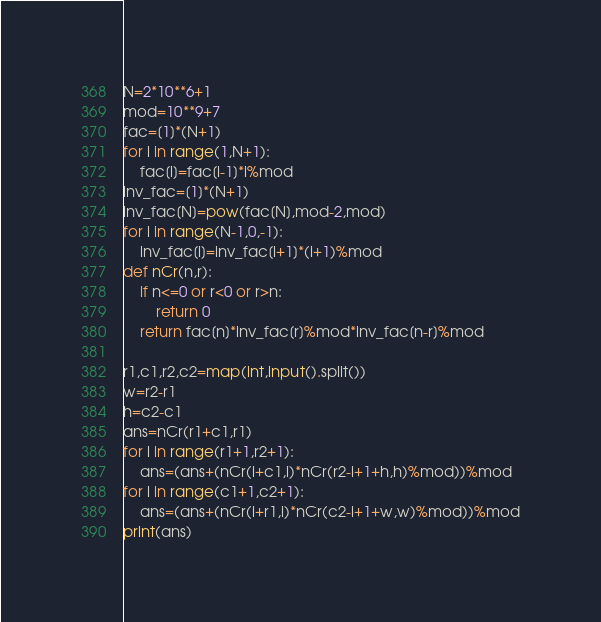Convert code to text. <code><loc_0><loc_0><loc_500><loc_500><_Python_>N=2*10**6+1
mod=10**9+7
fac=[1]*(N+1)
for i in range(1,N+1):
    fac[i]=fac[i-1]*i%mod
inv_fac=[1]*(N+1)
inv_fac[N]=pow(fac[N],mod-2,mod)
for i in range(N-1,0,-1):
    inv_fac[i]=inv_fac[i+1]*(i+1)%mod
def nCr(n,r):
    if n<=0 or r<0 or r>n:
        return 0
    return fac[n]*inv_fac[r]%mod*inv_fac[n-r]%mod

r1,c1,r2,c2=map(int,input().split())
w=r2-r1
h=c2-c1
ans=nCr(r1+c1,r1)
for i in range(r1+1,r2+1):
    ans=(ans+(nCr(i+c1,i)*nCr(r2-i+1+h,h)%mod))%mod
for i in range(c1+1,c2+1):
    ans=(ans+(nCr(i+r1,i)*nCr(c2-i+1+w,w)%mod))%mod
print(ans)</code> 